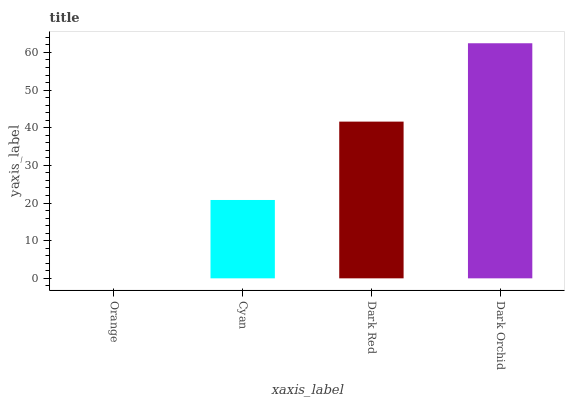Is Orange the minimum?
Answer yes or no. Yes. Is Dark Orchid the maximum?
Answer yes or no. Yes. Is Cyan the minimum?
Answer yes or no. No. Is Cyan the maximum?
Answer yes or no. No. Is Cyan greater than Orange?
Answer yes or no. Yes. Is Orange less than Cyan?
Answer yes or no. Yes. Is Orange greater than Cyan?
Answer yes or no. No. Is Cyan less than Orange?
Answer yes or no. No. Is Dark Red the high median?
Answer yes or no. Yes. Is Cyan the low median?
Answer yes or no. Yes. Is Cyan the high median?
Answer yes or no. No. Is Orange the low median?
Answer yes or no. No. 